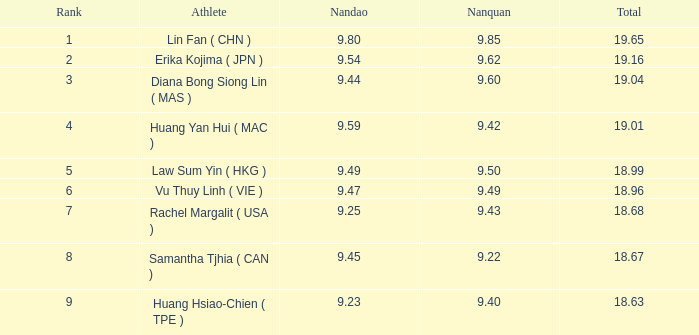49 and has a rank of 4? 9.42. 